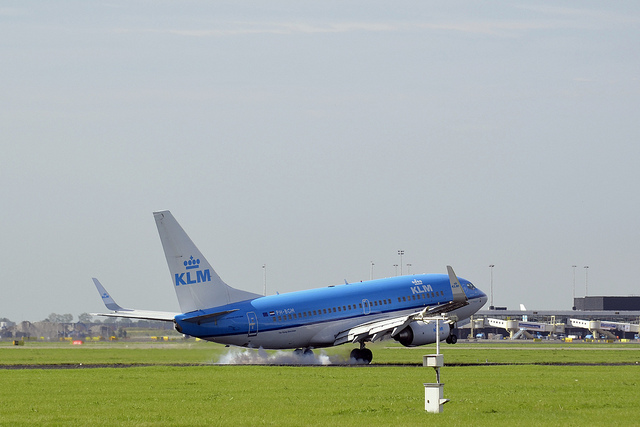<image>What military function is this built for? I don't know the specific military function this was built for. It could be for flying or storing. What military function is this built for? It is ambiguous what military function this is built for. It can be used for storing, flying, or bombing. 